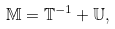<formula> <loc_0><loc_0><loc_500><loc_500>\mathbb { M } = \mathbb { T } ^ { - 1 } + \mathbb { U } ,</formula> 